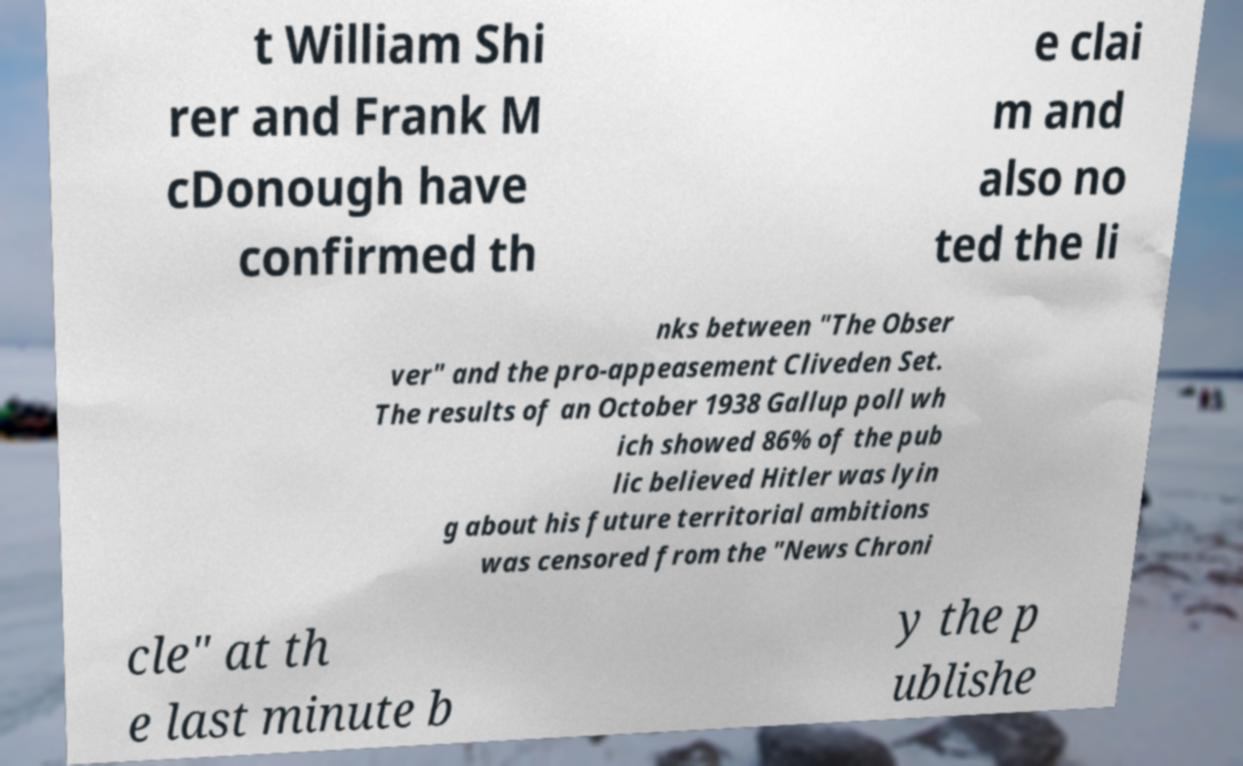Could you assist in decoding the text presented in this image and type it out clearly? t William Shi rer and Frank M cDonough have confirmed th e clai m and also no ted the li nks between "The Obser ver" and the pro-appeasement Cliveden Set. The results of an October 1938 Gallup poll wh ich showed 86% of the pub lic believed Hitler was lyin g about his future territorial ambitions was censored from the "News Chroni cle" at th e last minute b y the p ublishe 